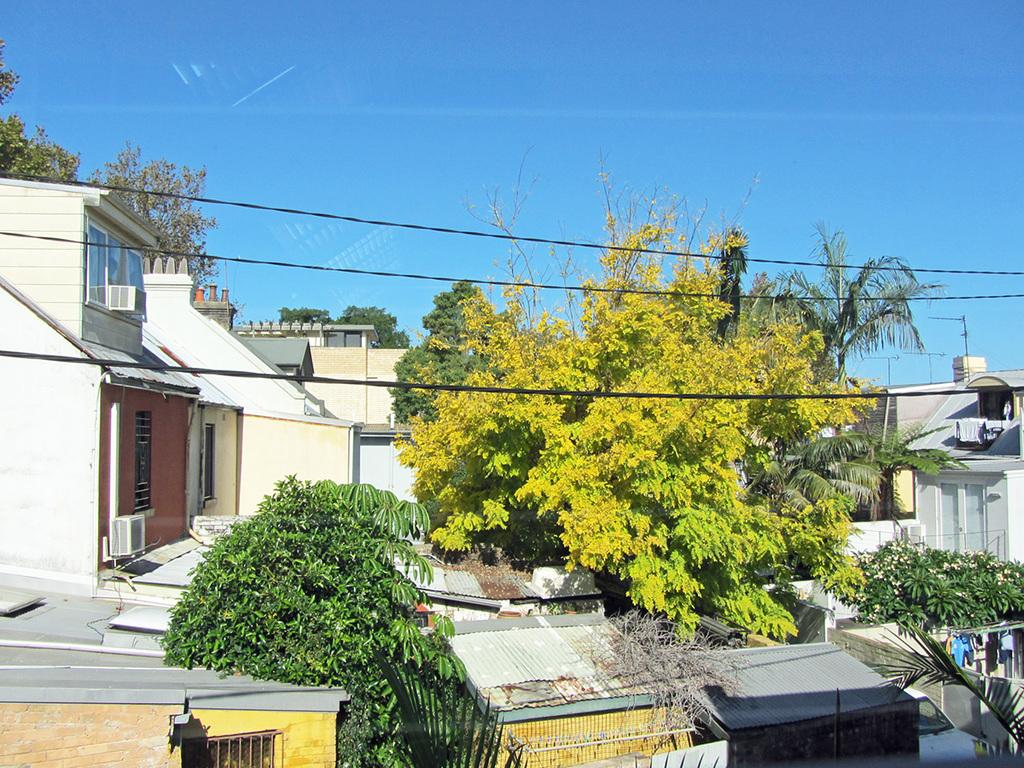What type of structures can be seen in the image? There are many houses in the image. What other natural elements are present in the image? There are trees in the image. Are there any man-made objects visible in the image? Yes, there are wires in the image. What is the color of the sky in the image? The sky is blue at the top of the image. Where is the desk located in the image? There is no desk present in the image. Can you see any pears in the image? There are no pears visible in the image. 